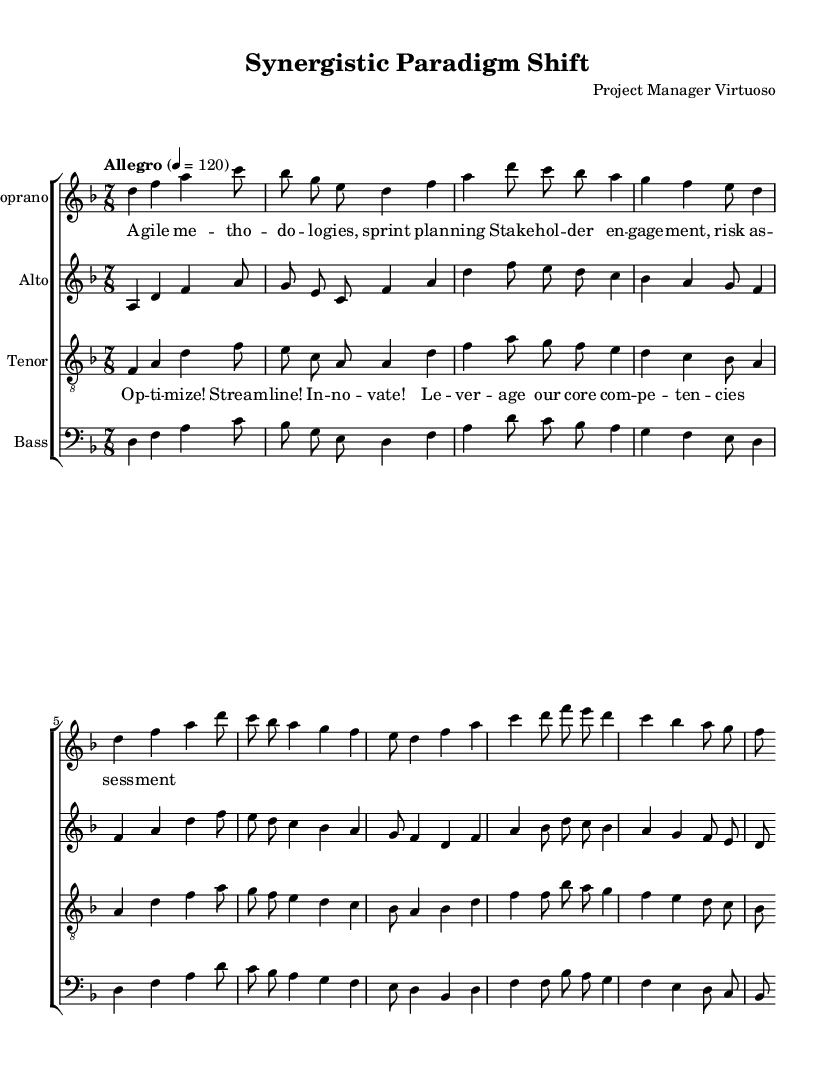What is the key signature of this music? The key signature is D minor, which has one flat (B flat). It's indicated at the beginning of the staff with the flat symbol.
Answer: D minor What is the time signature of this music? The time signature displayed at the beginning of the score is 7/8, which indicates there are seven beats in each measure and the eighth note gets one beat.
Answer: 7/8 What is the tempo marking of this music? The tempo marking is "Allegro" with a metronome marking of 120, meaning that the piece is to be played fast and lively at 120 beats per minute.
Answer: Allegro How many vocal parts are written in the score? The score contains four distinct vocal parts: Soprano, Alto, Tenor, and Bass. Each part is notated on separate staves.
Answer: Four What is the primary theme expressed in the lyrics of the verse? The lyrics in the verse discuss themes of agile methodologies and stakeholder engagement, indicating a focus on business practices in a corporate context.
Answer: Agile methodologies In the chorus, what action verbs are repeated to emphasize themes of productivity? The action verbs "optimize," "streamline," and "innovate" are used in the chorus to emphasize concepts related to efficiency and productivity.
Answer: Optimize, streamline, innovate 